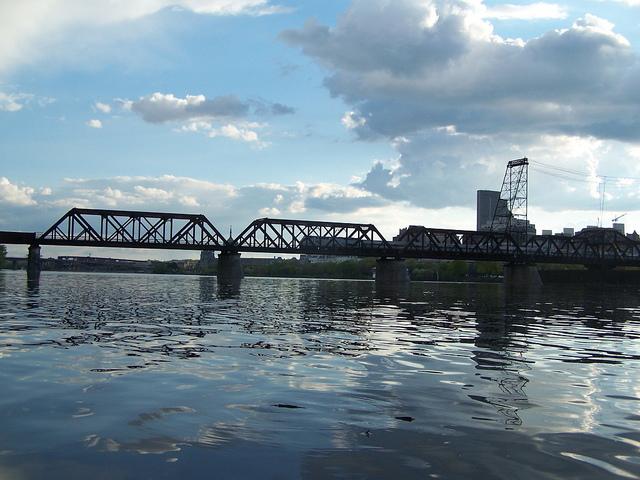Which of the buildings appears tallest?
Quick response, please. One behind bridge. What's in the water?
Quick response, please. Fish. Are people visible in this photo?
Short answer required. No. What is on the bridge?
Be succinct. Train. What is driving across the bridge?
Give a very brief answer. Train. Is the bridge wooden?
Concise answer only. No. Is there a boat underneath the bridge?
Be succinct. No. Is the water really high?
Quick response, please. Yes. Is there any boat seen?
Write a very short answer. No. What kind of boat is in the center of the picture?
Answer briefly. None. What bridge is this?
Write a very short answer. Train bridge. How calm is the water?
Short answer required. Calm. Is the sky clear?
Short answer required. No. 